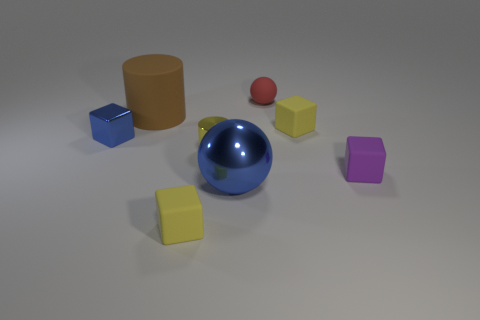Add 1 tiny yellow shiny objects. How many objects exist? 9 Subtract all spheres. How many objects are left? 6 Subtract all blue balls. Subtract all yellow shiny cylinders. How many objects are left? 6 Add 2 red matte objects. How many red matte objects are left? 3 Add 6 red matte things. How many red matte things exist? 7 Subtract 0 cyan cylinders. How many objects are left? 8 